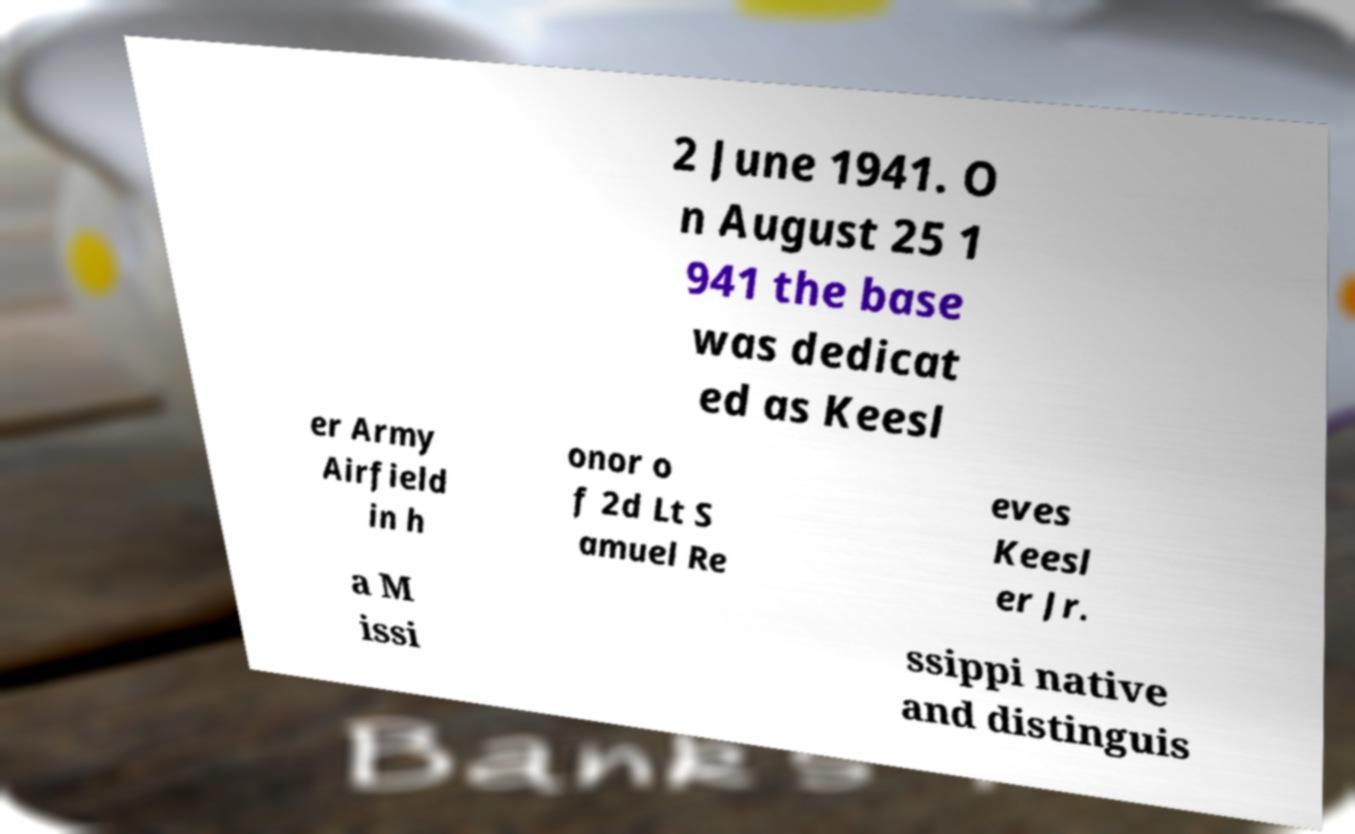I need the written content from this picture converted into text. Can you do that? 2 June 1941. O n August 25 1 941 the base was dedicat ed as Keesl er Army Airfield in h onor o f 2d Lt S amuel Re eves Keesl er Jr. a M issi ssippi native and distinguis 